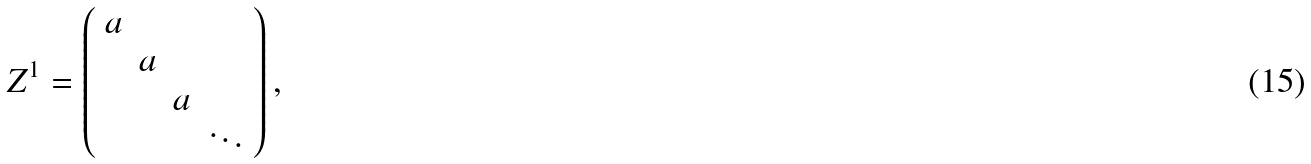<formula> <loc_0><loc_0><loc_500><loc_500>Z ^ { 1 } = \left ( \begin{array} { c c c c } a & & & \\ & a & & \\ & & a & \\ & & & \ddots \end{array} \right ) ,</formula> 